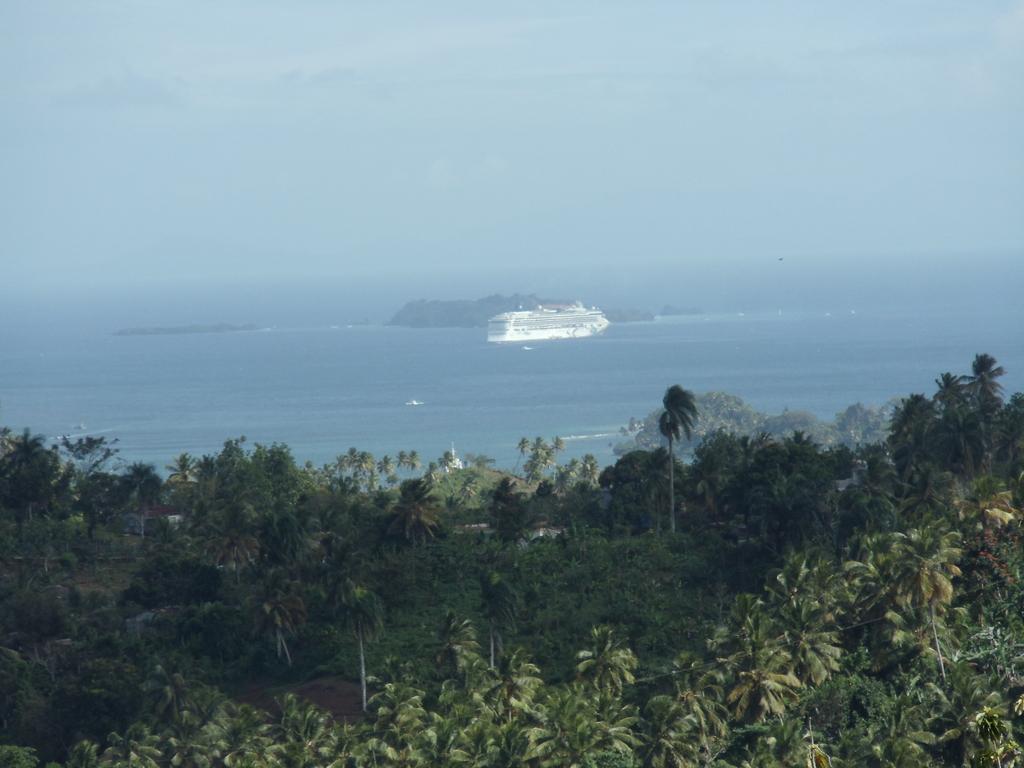How would you summarize this image in a sentence or two? In this picture we can see ocean. On the bottom we can see many trees. Here we can see ship which is in white color. Beside that there is a mountain. On the top we can see sky and clouds. 